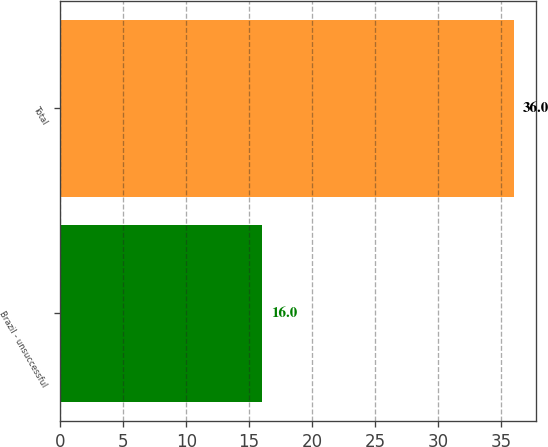<chart> <loc_0><loc_0><loc_500><loc_500><bar_chart><fcel>Brazil - unsuccessful<fcel>Total<nl><fcel>16<fcel>36<nl></chart> 